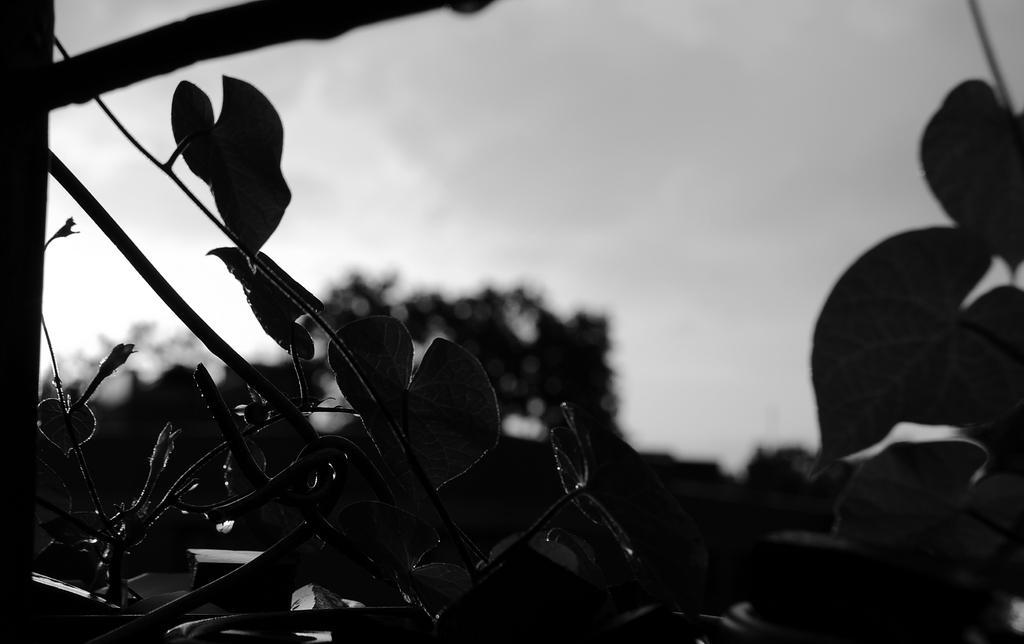Please provide a concise description of this image. In this image I can see few leafs, few trees and I can see this image is black and white in colour. 